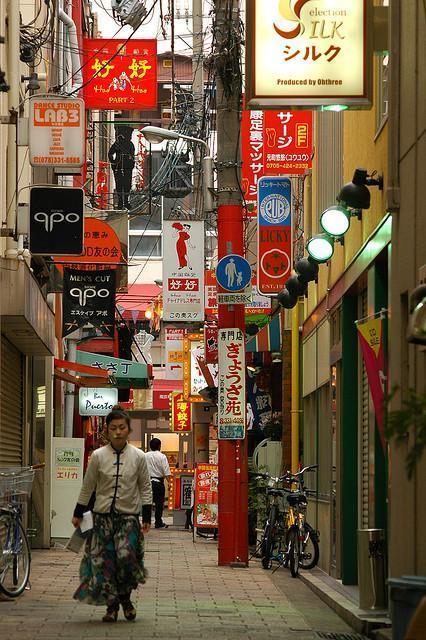How many bikes in this photo?
Give a very brief answer. 3. How many signs are black?
Give a very brief answer. 2. How many bicycles can you see?
Give a very brief answer. 3. How many clear cups are there?
Give a very brief answer. 0. 